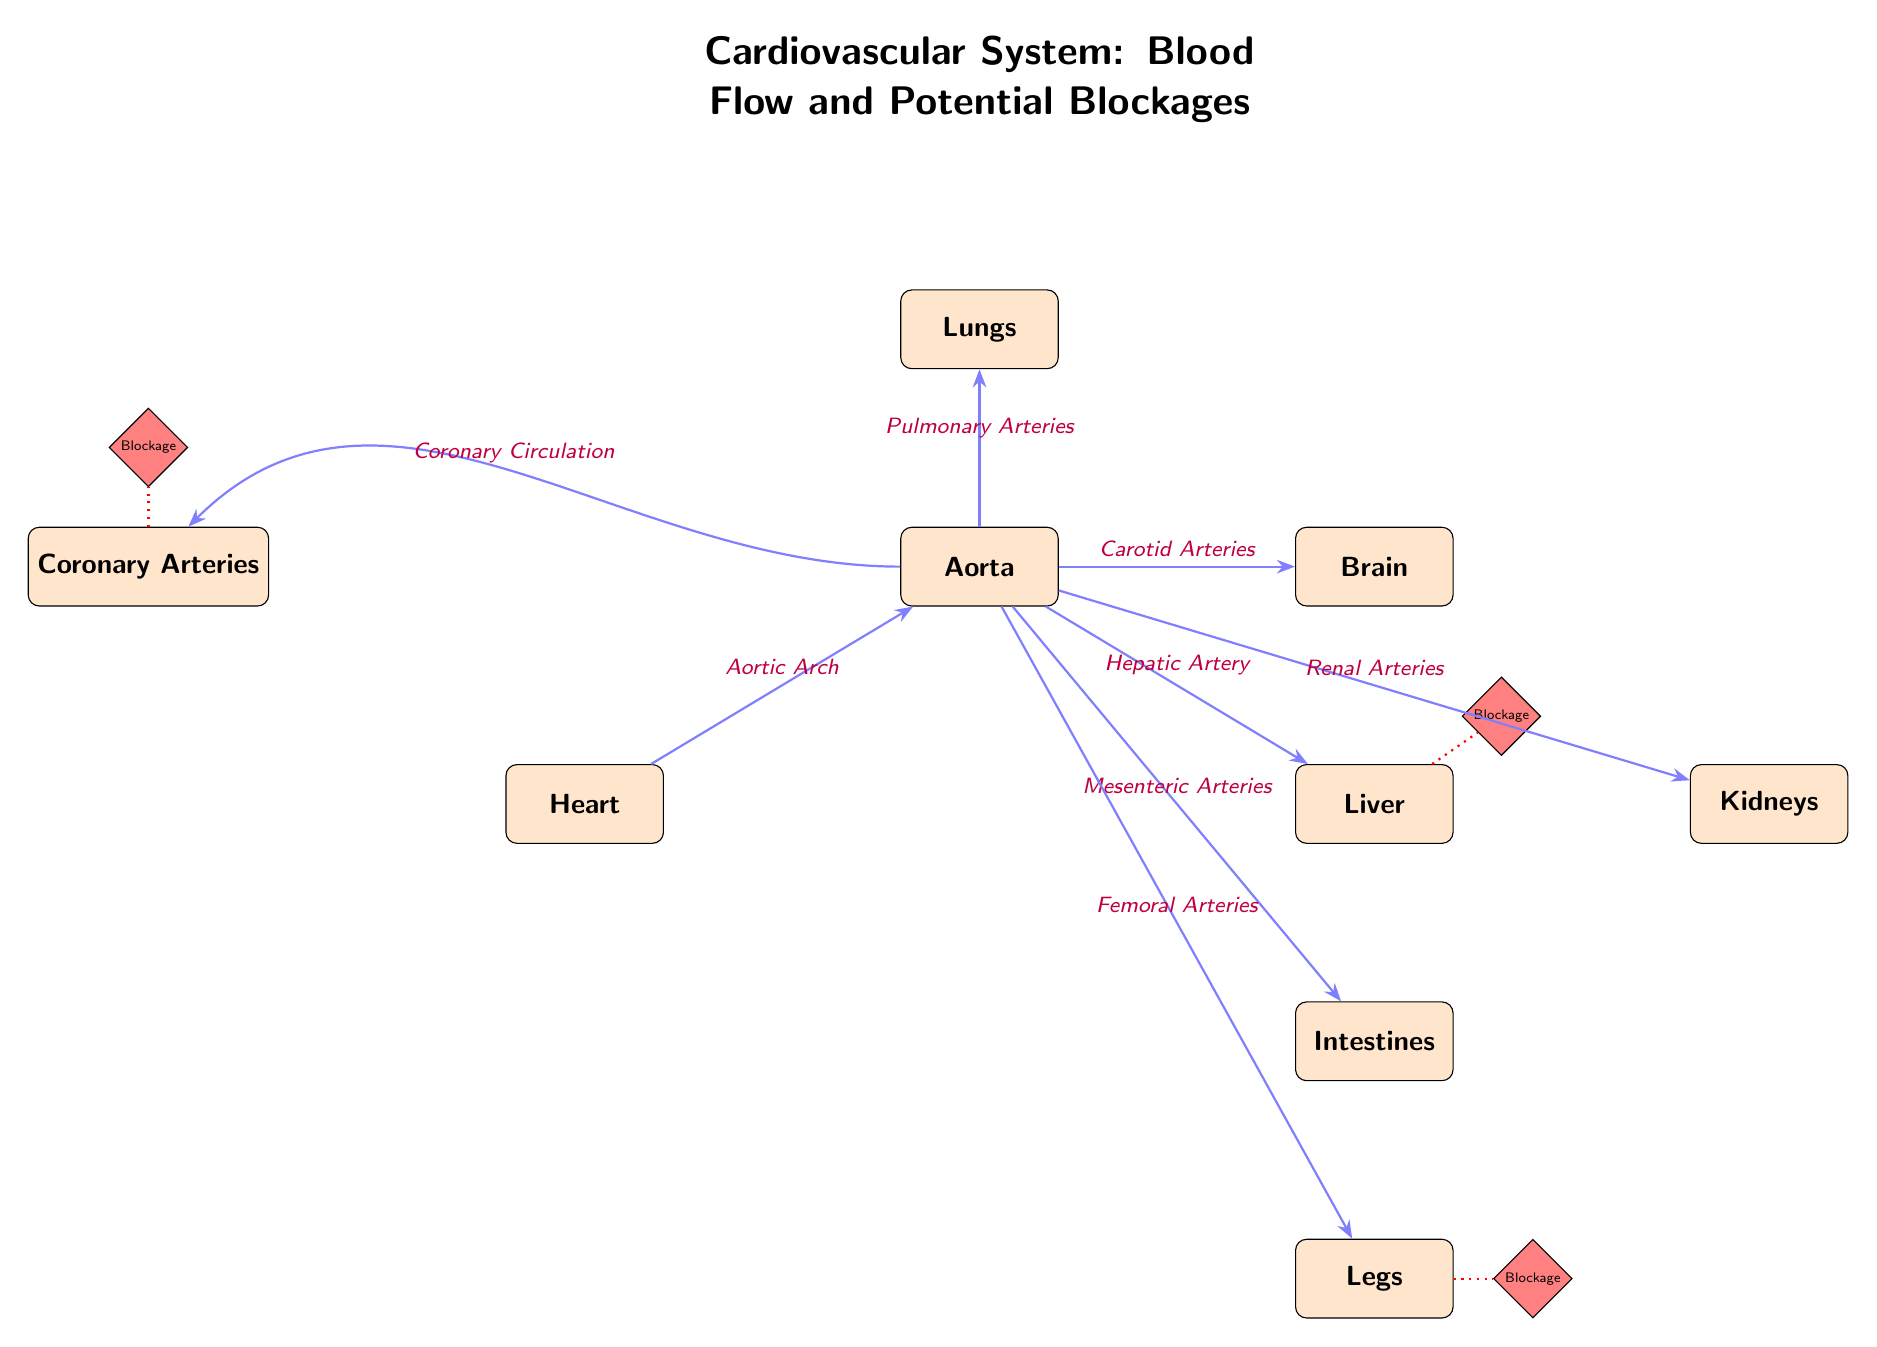What organ is directly connected to the Heart? The diagram shows an arrow labeled "Aortic Arch" leading from the Heart to the Aorta, indicating that the Aorta is the next organ in the flow of blood from the Heart.
Answer: Aorta How many blockages are indicated in the diagram? The diagram depicts three blockages labeled accordingly, one above the Coronary Arteries, one above the Liver, and one adjacent to the Legs. Counting these, the total is three blockages.
Answer: 3 What is the organ above the Aorta? According to the diagram, there is an organ labeled "Lungs" located directly above the Aorta, indicating its placement in relation to the Aorta.
Answer: Lungs How does blood flow from the Aorta to the Brain? The diagram shows a flow arrow leading from the Aorta to the Brain, labeled with "Carotid Arteries." This indicates that the Carotid Arteries are the vessels through which blood travels from the Aorta to the Brain.
Answer: Carotid Arteries Which organ has a blockage indicated in the diagram? The diagram has a blockage indicated above the Coronary Arteries, above the Liver, and next to the Legs. Thus, these three organs have indicated blockages.
Answer: Coronary Arteries, Liver, Legs What type of arteries carry blood from the Aorta to the Lungs? The diagram states that blood flows from the Aorta to the Lungs through the "Pulmonary Arteries," showing the specific vessels involved in this connection.
Answer: Pulmonary Arteries What is the flow path from the Heart to the Legs? Starting from the Heart, blood flows into the Aorta, then through the Femoral Arteries to reach the Legs, as indicated by the labeled directional arrows in the diagram.
Answer: Aorta to Femoral Arteries What is the shape of the blockages shown in the diagram? The diagram illustrates the blockages in a diamond shape, filled in red, making them visually distinct from the other elements depicted in the diagram.
Answer: Diamond 